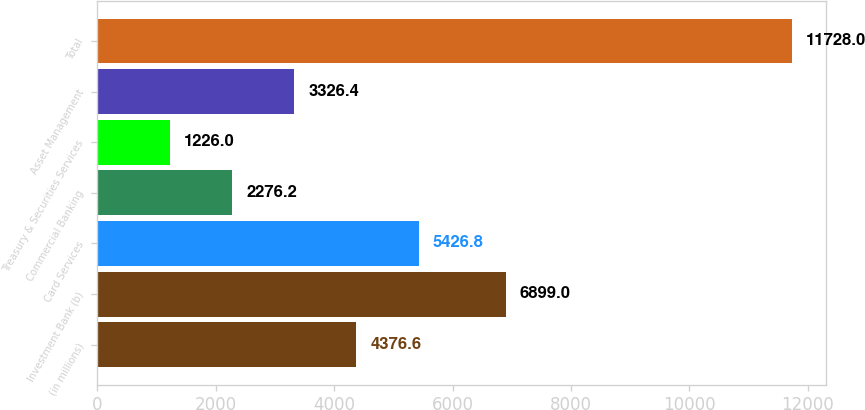Convert chart. <chart><loc_0><loc_0><loc_500><loc_500><bar_chart><fcel>(in millions)<fcel>Investment Bank (b)<fcel>Card Services<fcel>Commercial Banking<fcel>Treasury & Securities Services<fcel>Asset Management<fcel>Total<nl><fcel>4376.6<fcel>6899<fcel>5426.8<fcel>2276.2<fcel>1226<fcel>3326.4<fcel>11728<nl></chart> 